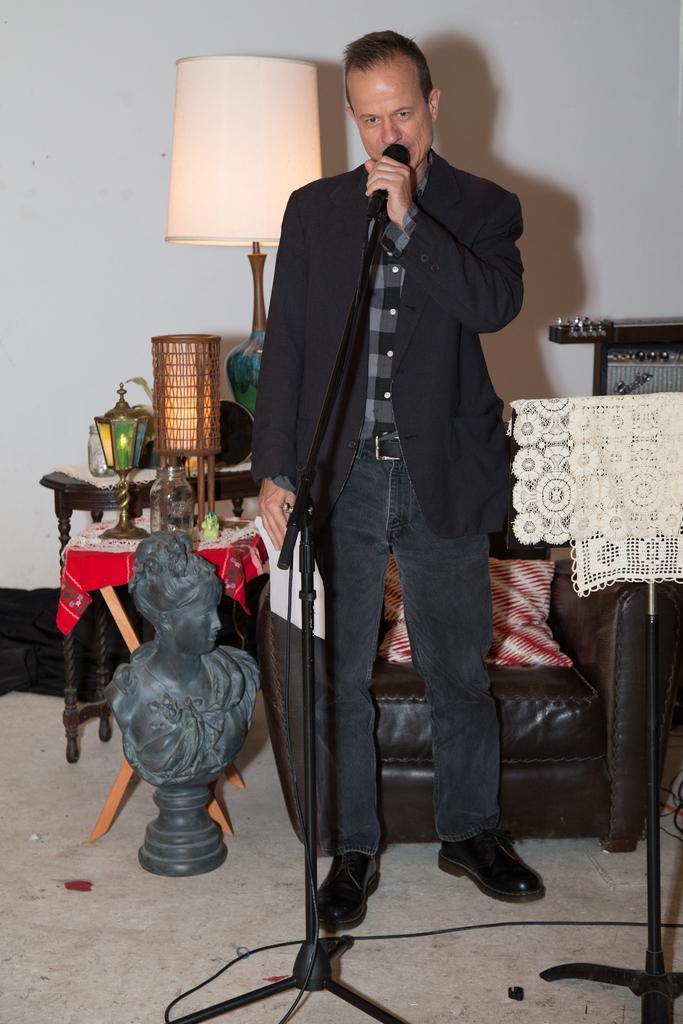In one or two sentences, can you explain what this image depicts? In this image there is a person is standing and holding a microphone is wearing shoes. Backside to him there is a chair having cousin in it. Left side there is an idol and back to it there is a table having lamp and glass jar. Right side there is a stand having cloth placed on it. Background there is a wall. 